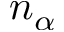Convert formula to latex. <formula><loc_0><loc_0><loc_500><loc_500>n _ { \alpha }</formula> 